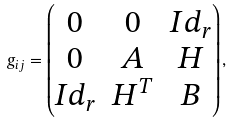Convert formula to latex. <formula><loc_0><loc_0><loc_500><loc_500>g _ { i j } = \begin{pmatrix} 0 & 0 & I d _ { r } \\ 0 & A & H \\ I d _ { r } & H ^ { T } & B \end{pmatrix} ,</formula> 